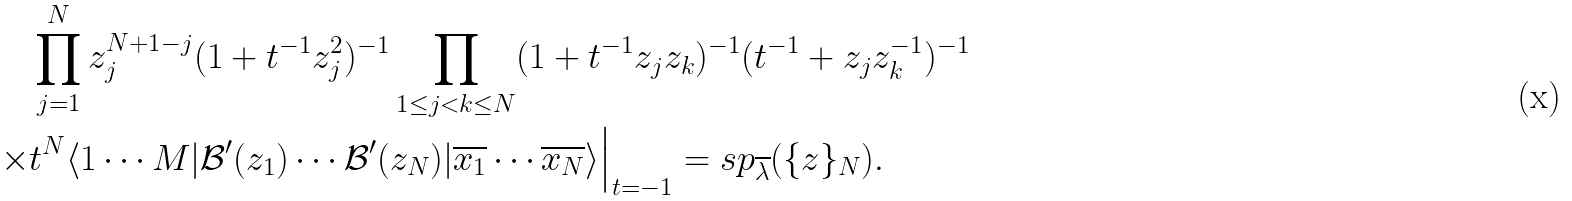<formula> <loc_0><loc_0><loc_500><loc_500>& \prod _ { j = 1 } ^ { N } z _ { j } ^ { N + 1 - j } ( 1 + t ^ { - 1 } z _ { j } ^ { 2 } ) ^ { - 1 } \prod _ { 1 \leq j < k \leq N } ( 1 + t ^ { - 1 } z _ { j } z _ { k } ) ^ { - 1 } ( t ^ { - 1 } + z _ { j } z _ { k } ^ { - 1 } ) ^ { - 1 } \\ \times & t ^ { N } \langle 1 \cdots M | \mathcal { B } ^ { \prime } ( z _ { 1 } ) \cdots \mathcal { B } ^ { \prime } ( z _ { N } ) | \overline { x _ { 1 } } \cdots \overline { x _ { N } } \rangle \Big | _ { t = - 1 } = s p _ { \overline { \lambda } } ( \{ z \} _ { N } ) .</formula> 